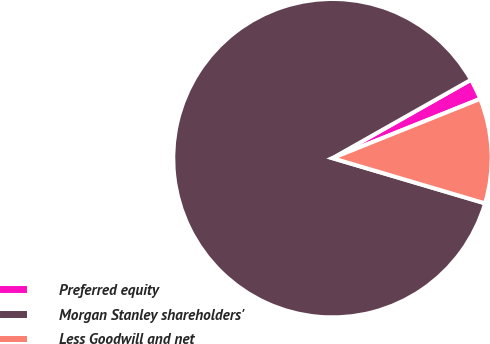<chart> <loc_0><loc_0><loc_500><loc_500><pie_chart><fcel>Preferred equity<fcel>Morgan Stanley shareholders'<fcel>Less Goodwill and net<nl><fcel>2.12%<fcel>87.23%<fcel>10.66%<nl></chart> 